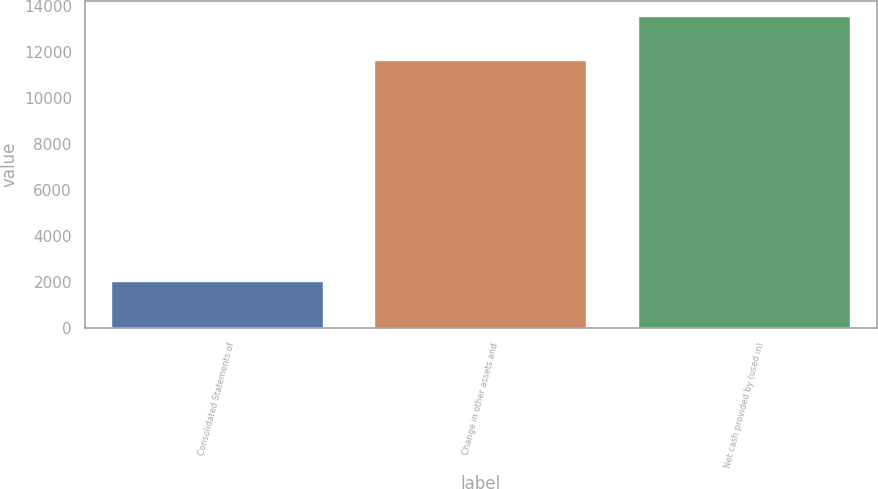<chart> <loc_0><loc_0><loc_500><loc_500><bar_chart><fcel>Consolidated Statements of<fcel>Change in other assets and<fcel>Net cash provided by (used in)<nl><fcel>2015<fcel>11601<fcel>13518.2<nl></chart> 